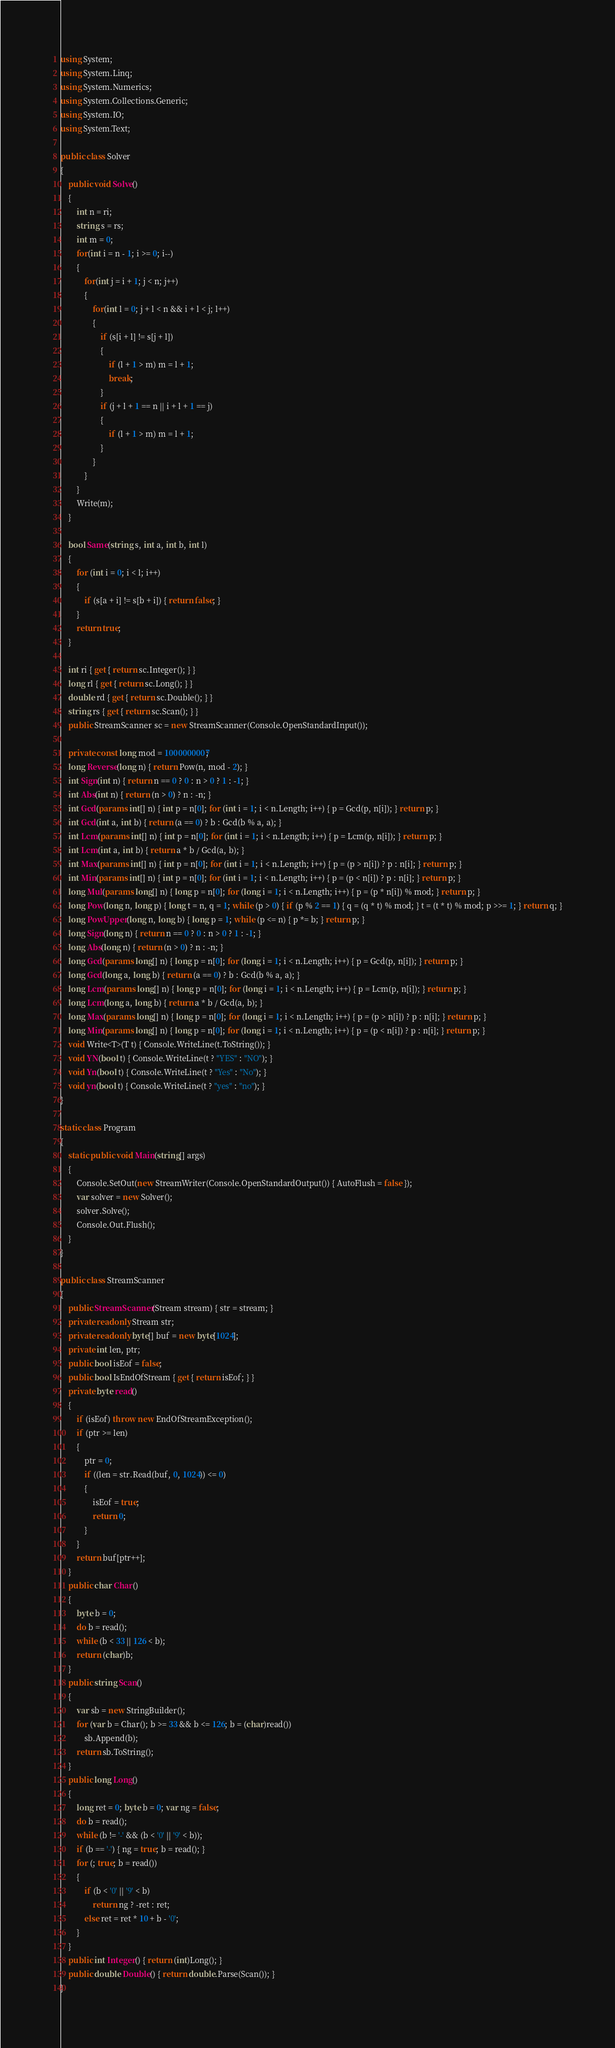<code> <loc_0><loc_0><loc_500><loc_500><_C#_>using System;
using System.Linq;
using System.Numerics;
using System.Collections.Generic;
using System.IO;
using System.Text;

public class Solver
{
    public void Solve()
    {
        int n = ri;
        string s = rs;
        int m = 0;
        for(int i = n - 1; i >= 0; i--)
        {
            for(int j = i + 1; j < n; j++)
            {
                for(int l = 0; j + l < n && i + l < j; l++)
                {
                    if (s[i + l] != s[j + l])
                    {
                        if (l + 1 > m) m = l + 1;
                        break;
                    }
                    if (j + l + 1 == n || i + l + 1 == j)
                    {
                        if (l + 1 > m) m = l + 1;
                    }
                }
            }
        }
        Write(m);
    }

    bool Same(string s, int a, int b, int l)
    {
        for (int i = 0; i < l; i++)
        {
            if (s[a + i] != s[b + i]) { return false; }
        }
        return true;
    }

    int ri { get { return sc.Integer(); } }
    long rl { get { return sc.Long(); } }
    double rd { get { return sc.Double(); } }
    string rs { get { return sc.Scan(); } }
    public StreamScanner sc = new StreamScanner(Console.OpenStandardInput());

    private const long mod = 1000000007;
    long Reverse(long n) { return Pow(n, mod - 2); }
    int Sign(int n) { return n == 0 ? 0 : n > 0 ? 1 : -1; }
    int Abs(int n) { return (n > 0) ? n : -n; }
    int Gcd(params int[] n) { int p = n[0]; for (int i = 1; i < n.Length; i++) { p = Gcd(p, n[i]); } return p; }
    int Gcd(int a, int b) { return (a == 0) ? b : Gcd(b % a, a); }
    int Lcm(params int[] n) { int p = n[0]; for (int i = 1; i < n.Length; i++) { p = Lcm(p, n[i]); } return p; }
    int Lcm(int a, int b) { return a * b / Gcd(a, b); }
    int Max(params int[] n) { int p = n[0]; for (int i = 1; i < n.Length; i++) { p = (p > n[i]) ? p : n[i]; } return p; }
    int Min(params int[] n) { int p = n[0]; for (int i = 1; i < n.Length; i++) { p = (p < n[i]) ? p : n[i]; } return p; }
    long Mul(params long[] n) { long p = n[0]; for (long i = 1; i < n.Length; i++) { p = (p * n[i]) % mod; } return p; }
    long Pow(long n, long p) { long t = n, q = 1; while (p > 0) { if (p % 2 == 1) { q = (q * t) % mod; } t = (t * t) % mod; p >>= 1; } return q; }
    long PowUpper(long n, long b) { long p = 1; while (p <= n) { p *= b; } return p; }
    long Sign(long n) { return n == 0 ? 0 : n > 0 ? 1 : -1; }
    long Abs(long n) { return (n > 0) ? n : -n; }
    long Gcd(params long[] n) { long p = n[0]; for (long i = 1; i < n.Length; i++) { p = Gcd(p, n[i]); } return p; }
    long Gcd(long a, long b) { return (a == 0) ? b : Gcd(b % a, a); }
    long Lcm(params long[] n) { long p = n[0]; for (long i = 1; i < n.Length; i++) { p = Lcm(p, n[i]); } return p; }
    long Lcm(long a, long b) { return a * b / Gcd(a, b); }
    long Max(params long[] n) { long p = n[0]; for (long i = 1; i < n.Length; i++) { p = (p > n[i]) ? p : n[i]; } return p; }
    long Min(params long[] n) { long p = n[0]; for (long i = 1; i < n.Length; i++) { p = (p < n[i]) ? p : n[i]; } return p; }
    void Write<T>(T t) { Console.WriteLine(t.ToString()); }
    void YN(bool t) { Console.WriteLine(t ? "YES" : "NO"); }
    void Yn(bool t) { Console.WriteLine(t ? "Yes" : "No"); }
    void yn(bool t) { Console.WriteLine(t ? "yes" : "no"); }
}

static class Program
{
    static public void Main(string[] args)
    {
        Console.SetOut(new StreamWriter(Console.OpenStandardOutput()) { AutoFlush = false });
        var solver = new Solver();
        solver.Solve();
        Console.Out.Flush();
    }
}

public class StreamScanner
{
    public StreamScanner(Stream stream) { str = stream; }
    private readonly Stream str;
    private readonly byte[] buf = new byte[1024];
    private int len, ptr;
    public bool isEof = false;
    public bool IsEndOfStream { get { return isEof; } }
    private byte read()
    {
        if (isEof) throw new EndOfStreamException();
        if (ptr >= len)
        {
            ptr = 0;
            if ((len = str.Read(buf, 0, 1024)) <= 0)
            {
                isEof = true;
                return 0;
            }
        }
        return buf[ptr++];
    }
    public char Char()
    {
        byte b = 0;
        do b = read();
        while (b < 33 || 126 < b);
        return (char)b;
    }
    public string Scan()
    {
        var sb = new StringBuilder();
        for (var b = Char(); b >= 33 && b <= 126; b = (char)read())
            sb.Append(b);
        return sb.ToString();
    }
    public long Long()
    {
        long ret = 0; byte b = 0; var ng = false;
        do b = read();
        while (b != '-' && (b < '0' || '9' < b));
        if (b == '-') { ng = true; b = read(); }
        for (; true; b = read())
        {
            if (b < '0' || '9' < b)
                return ng ? -ret : ret;
            else ret = ret * 10 + b - '0';
        }
    }
    public int Integer() { return (int)Long(); }
    public double Double() { return double.Parse(Scan()); }
}
</code> 